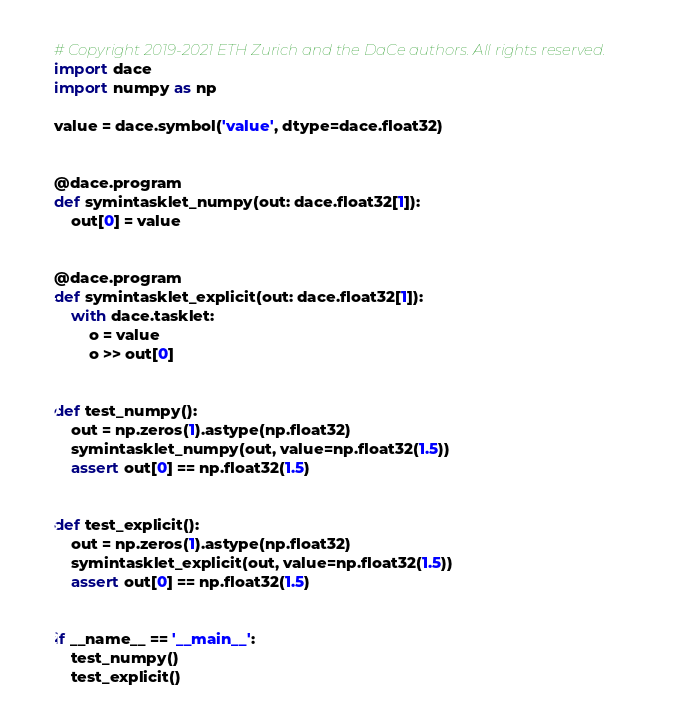Convert code to text. <code><loc_0><loc_0><loc_500><loc_500><_Python_># Copyright 2019-2021 ETH Zurich and the DaCe authors. All rights reserved.
import dace
import numpy as np

value = dace.symbol('value', dtype=dace.float32)


@dace.program
def symintasklet_numpy(out: dace.float32[1]):
    out[0] = value


@dace.program
def symintasklet_explicit(out: dace.float32[1]):
    with dace.tasklet:
        o = value
        o >> out[0]


def test_numpy():
    out = np.zeros(1).astype(np.float32)
    symintasklet_numpy(out, value=np.float32(1.5))
    assert out[0] == np.float32(1.5)


def test_explicit():
    out = np.zeros(1).astype(np.float32)
    symintasklet_explicit(out, value=np.float32(1.5))
    assert out[0] == np.float32(1.5)


if __name__ == '__main__':
    test_numpy()
    test_explicit()
</code> 